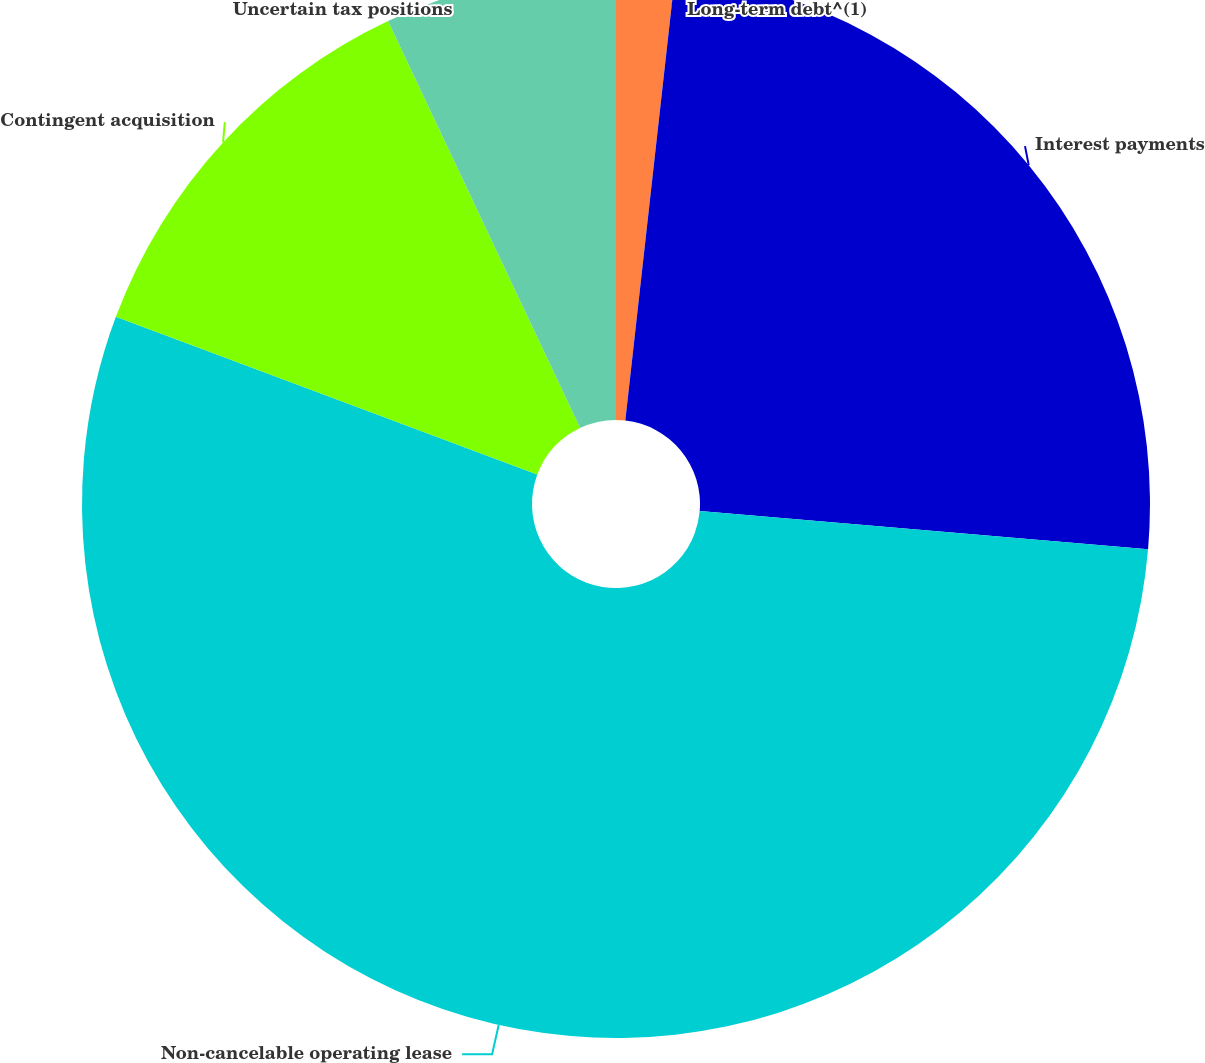Convert chart to OTSL. <chart><loc_0><loc_0><loc_500><loc_500><pie_chart><fcel>Long-term debt^(1)<fcel>Interest payments<fcel>Non-cancelable operating lease<fcel>Contingent acquisition<fcel>Uncertain tax positions<nl><fcel>1.77%<fcel>24.58%<fcel>54.35%<fcel>12.28%<fcel>7.02%<nl></chart> 